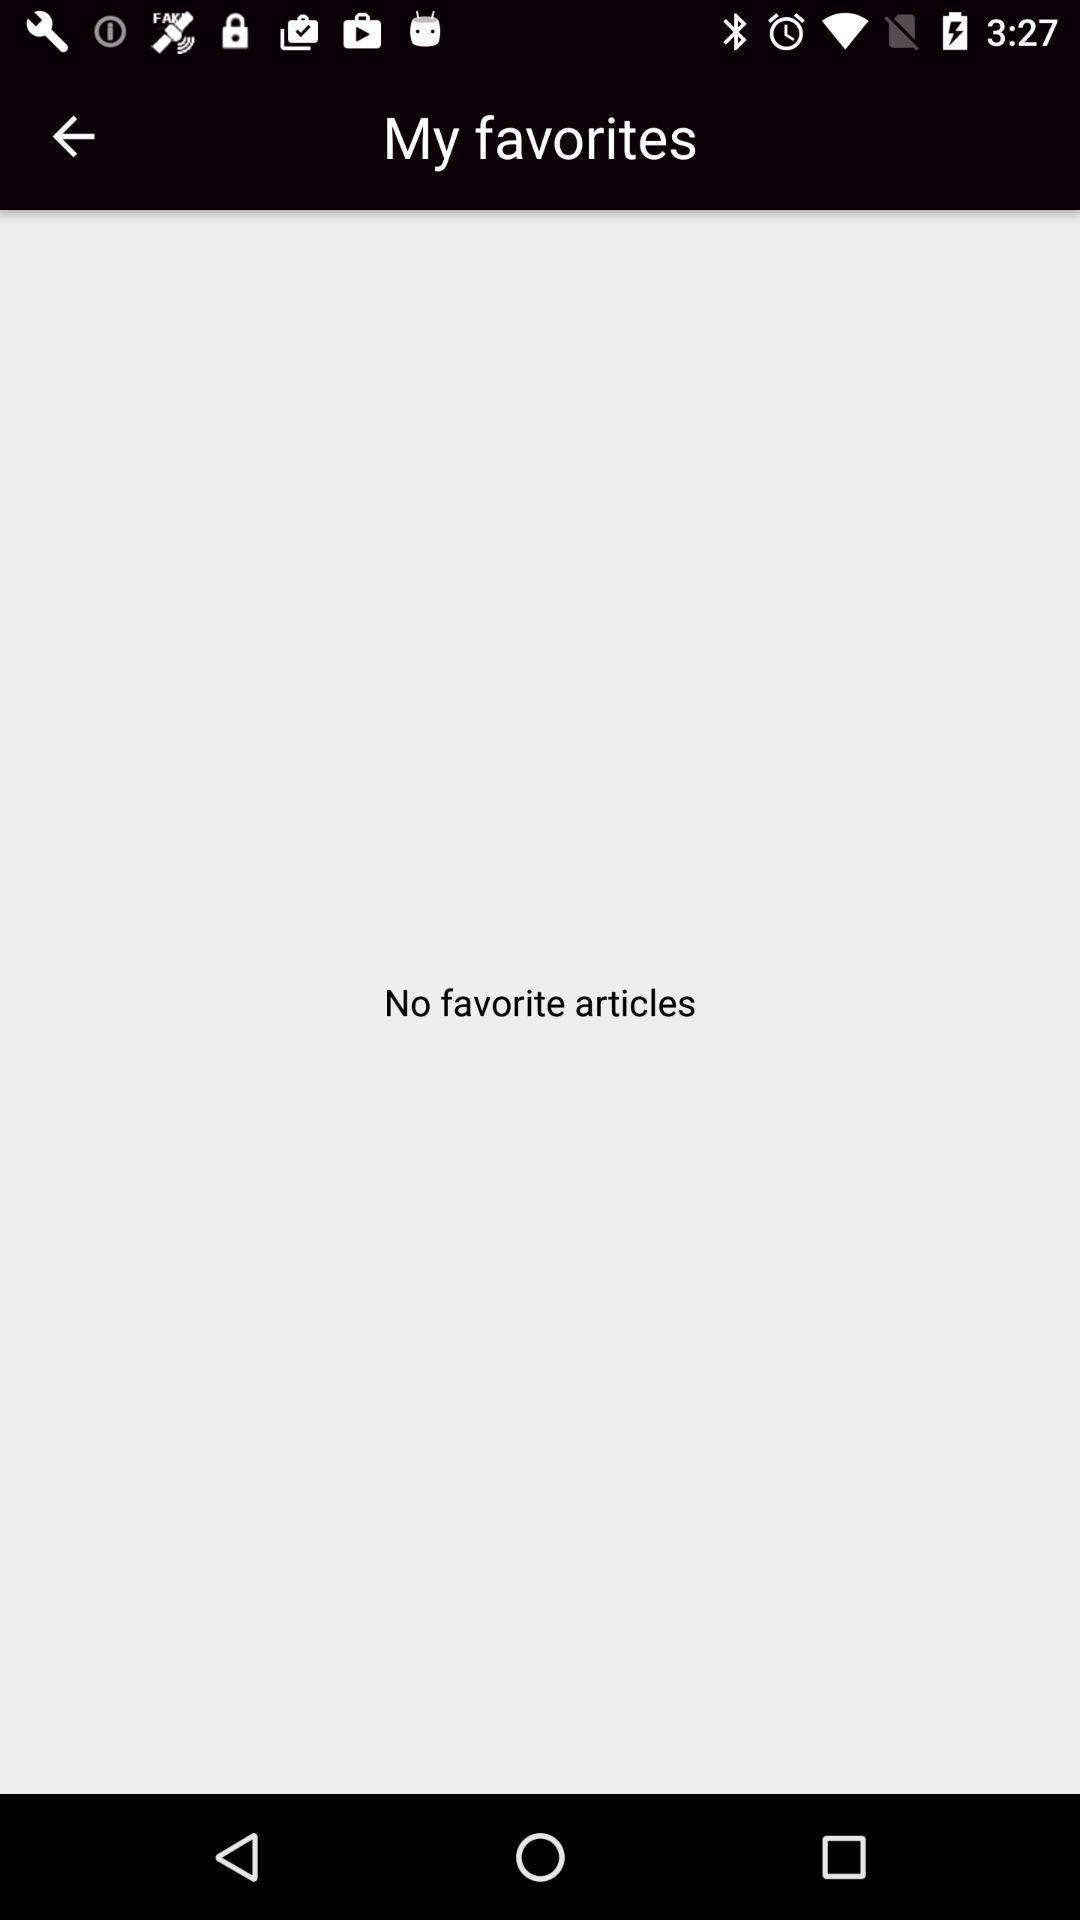Are there any favorite articles present on the screen? There are no favorite articles present on the screen. 